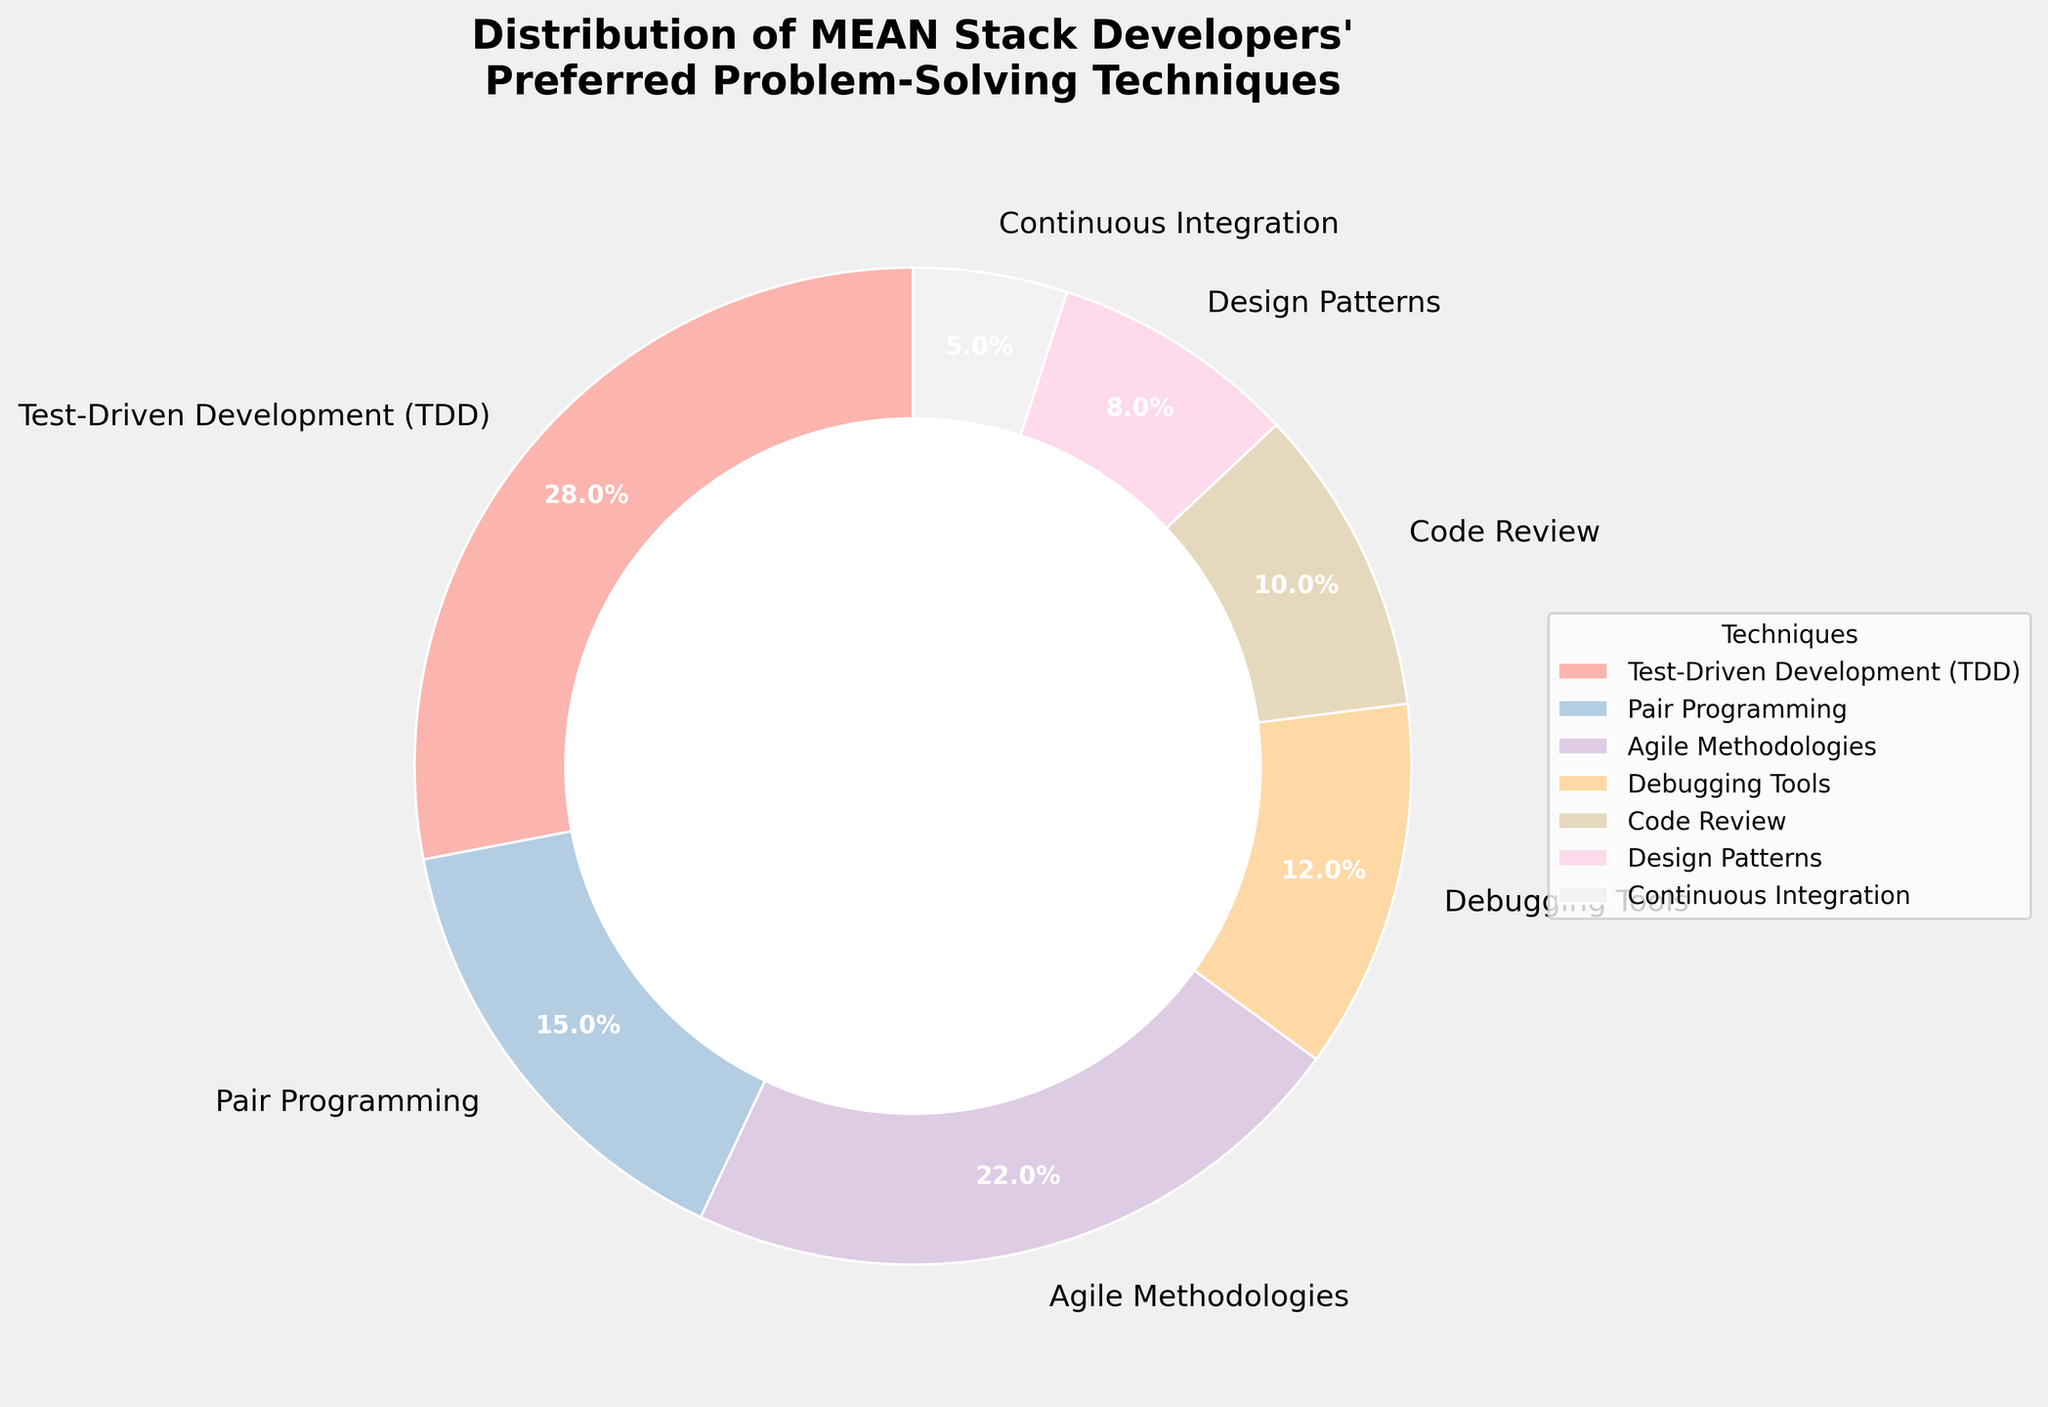What is the percentage of developers who prefer Test-Driven Development (TDD)? By looking at the segment labeled "Test-Driven Development (TDD)" on the pie chart, it can be observed that it represents 28% of the total.
Answer: 28% Which technique has the smallest percentage of developers, and what is that percentage? By examining the pie chart, the smallest segment corresponds to "Continuous Integration," which has a percentage of 5%.
Answer: Continuous Integration, 5% What is the combined percentage of developers who prefer Agile Methodologies and Pair Programming? The percentages for "Agile Methodologies" and "Pair Programming" are 22% and 15%, respectively. Adding these together gives 22% + 15% = 37%.
Answer: 37% Are there more developers who prefer Debugging Tools or Design Patterns? By how much? Referring to the pie chart, "Debugging Tools" has 12%, while "Design Patterns" has 8%. Subtracting these gives 12% - 8% = 4%. Therefore, more developers prefer Debugging Tools by 4%.
Answer: Debugging Tools by 4% Which two techniques together have the same percentage as Test-Driven Development (TDD)? The percentage for Test-Driven Development (TDD) is 28%. By checking the pie chart, we find that the sum of Pair Programming (15%) and Code Review (10%) is 15% + 10% = 25%, and the sum of Agile Methodologies (22%) and Continuous Integration (5%) is 22% + 5% = 27%. Thus, the two techniques that together sum close to 28% are Agile Methodologies (22%) and Continuous Integration (5%) = 27%.
Answer: Agile Methodologies and Continuous Integration What is the difference in percentage between the techniques with the highest and lowest values? The highest percentage technique is Test-Driven Development (TDD) with 28%, and the lowest is Continuous Integration with 5%. The difference is 28% - 5% = 23%.
Answer: 23% How many techniques have a percentage greater than 20%? By inspecting each segment of the pie chart, only two techniques have percentages greater than 20%: Test-Driven Development (TDD) with 28% and Agile Methodologies with 22%.
Answer: Two What is the percentage for Code Review and Design Patterns combined and compared with the percentage for Pair Programming? The percentages for Code Review and Design Patterns are 10% and 8%, respectively. Their combined percentage is 10% + 8% = 18%. Pair Programming has a percentage of 15%. Therefore, combined, Code Review and Design Patterns have 3% more than Pair Programming.
Answer: 18%, 3% more Which two techniques together constitute half of the developers' preferred techniques, and what are their percentages? To make up half, we need segments that add up to around 50%. Test-Driven Development (TDD) is 28%, and Agile Methodologies is 22%, giving 28% + 22% = 50%, which is precisely half.
Answer: Test-Driven Development (TDD) and Agile Methodologies, 50% What percentage of developers prefer techniques other than Test-Driven Development (TDD) and Agile Methodologies? Together, Test-Driven Development (TDD) and Agile Methodologies account for 28% + 22% = 50%. Therefore, the remaining percentage for other techniques is 100% - 50% = 50%.
Answer: 50% 